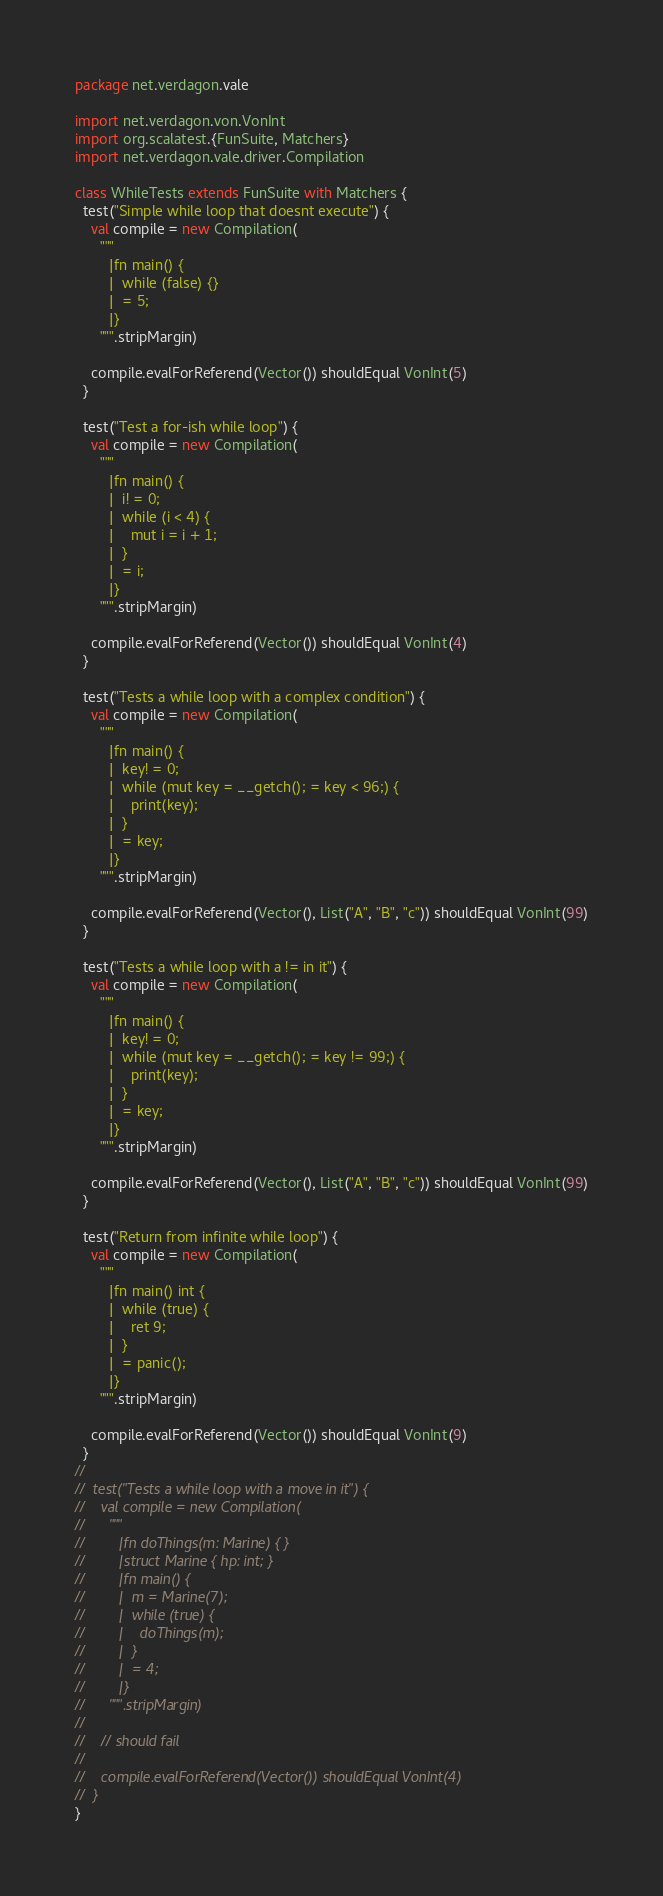<code> <loc_0><loc_0><loc_500><loc_500><_Scala_>package net.verdagon.vale

import net.verdagon.von.VonInt
import org.scalatest.{FunSuite, Matchers}
import net.verdagon.vale.driver.Compilation

class WhileTests extends FunSuite with Matchers {
  test("Simple while loop that doesnt execute") {
    val compile = new Compilation(
      """
        |fn main() {
        |  while (false) {}
        |  = 5;
        |}
      """.stripMargin)

    compile.evalForReferend(Vector()) shouldEqual VonInt(5)
  }

  test("Test a for-ish while loop") {
    val compile = new Compilation(
      """
        |fn main() {
        |  i! = 0;
        |  while (i < 4) {
        |    mut i = i + 1;
        |  }
        |  = i;
        |}
      """.stripMargin)

    compile.evalForReferend(Vector()) shouldEqual VonInt(4)
  }

  test("Tests a while loop with a complex condition") {
    val compile = new Compilation(
      """
        |fn main() {
        |  key! = 0;
        |  while (mut key = __getch(); = key < 96;) {
        |    print(key);
        |  }
        |  = key;
        |}
      """.stripMargin)

    compile.evalForReferend(Vector(), List("A", "B", "c")) shouldEqual VonInt(99)
  }

  test("Tests a while loop with a != in it") {
    val compile = new Compilation(
      """
        |fn main() {
        |  key! = 0;
        |  while (mut key = __getch(); = key != 99;) {
        |    print(key);
        |  }
        |  = key;
        |}
      """.stripMargin)

    compile.evalForReferend(Vector(), List("A", "B", "c")) shouldEqual VonInt(99)
  }

  test("Return from infinite while loop") {
    val compile = new Compilation(
      """
        |fn main() int {
        |  while (true) {
        |    ret 9;
        |  }
        |  = panic();
        |}
      """.stripMargin)

    compile.evalForReferend(Vector()) shouldEqual VonInt(9)
  }
//
//  test("Tests a while loop with a move in it") {
//    val compile = new Compilation(
//      """
//        |fn doThings(m: Marine) { }
//        |struct Marine { hp: int; }
//        |fn main() {
//        |  m = Marine(7);
//        |  while (true) {
//        |    doThings(m);
//        |  }
//        |  = 4;
//        |}
//      """.stripMargin)
//
//    // should fail
//
//    compile.evalForReferend(Vector()) shouldEqual VonInt(4)
//  }
}
</code> 